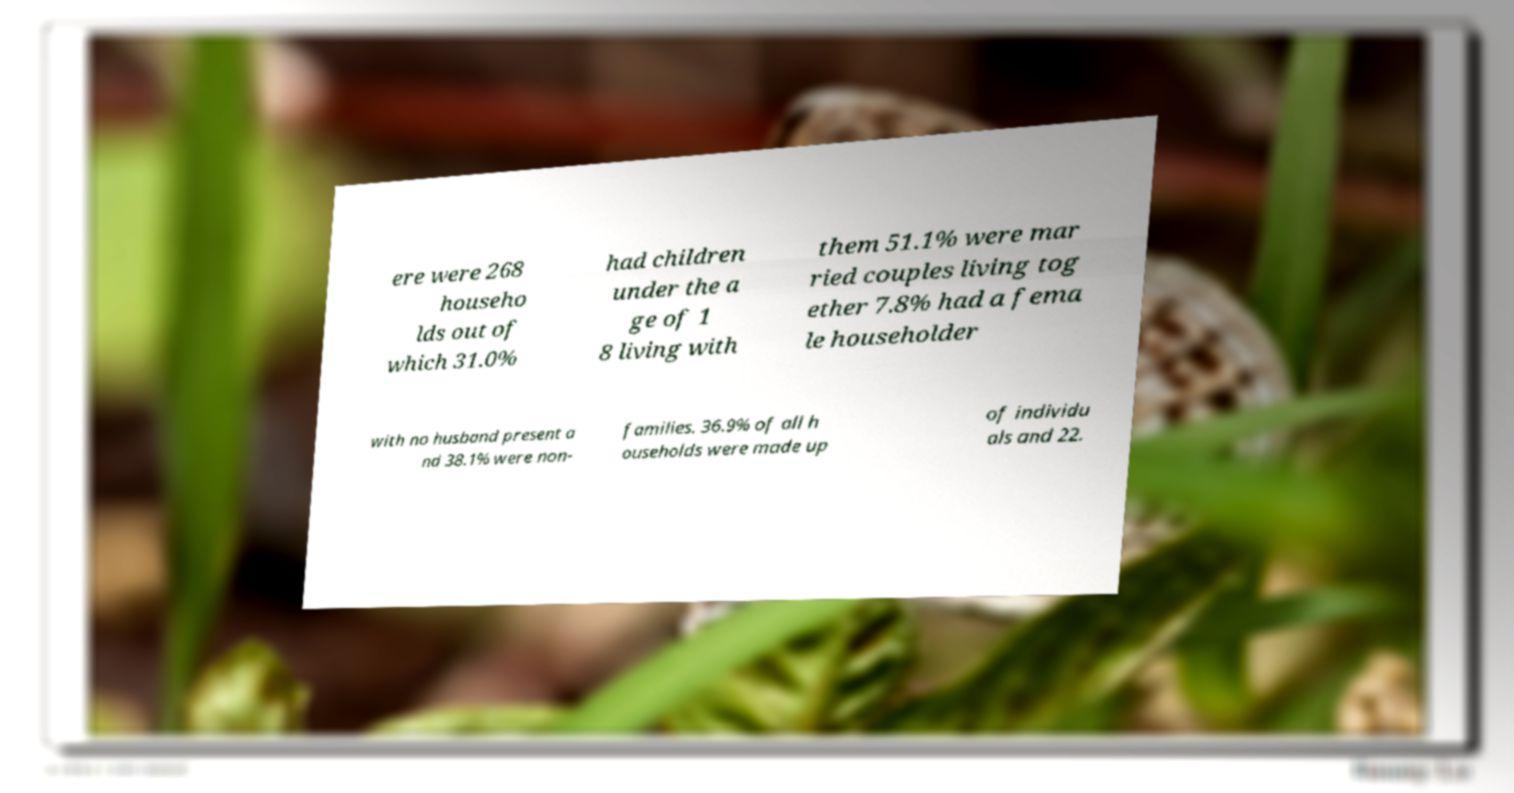For documentation purposes, I need the text within this image transcribed. Could you provide that? ere were 268 househo lds out of which 31.0% had children under the a ge of 1 8 living with them 51.1% were mar ried couples living tog ether 7.8% had a fema le householder with no husband present a nd 38.1% were non- families. 36.9% of all h ouseholds were made up of individu als and 22. 